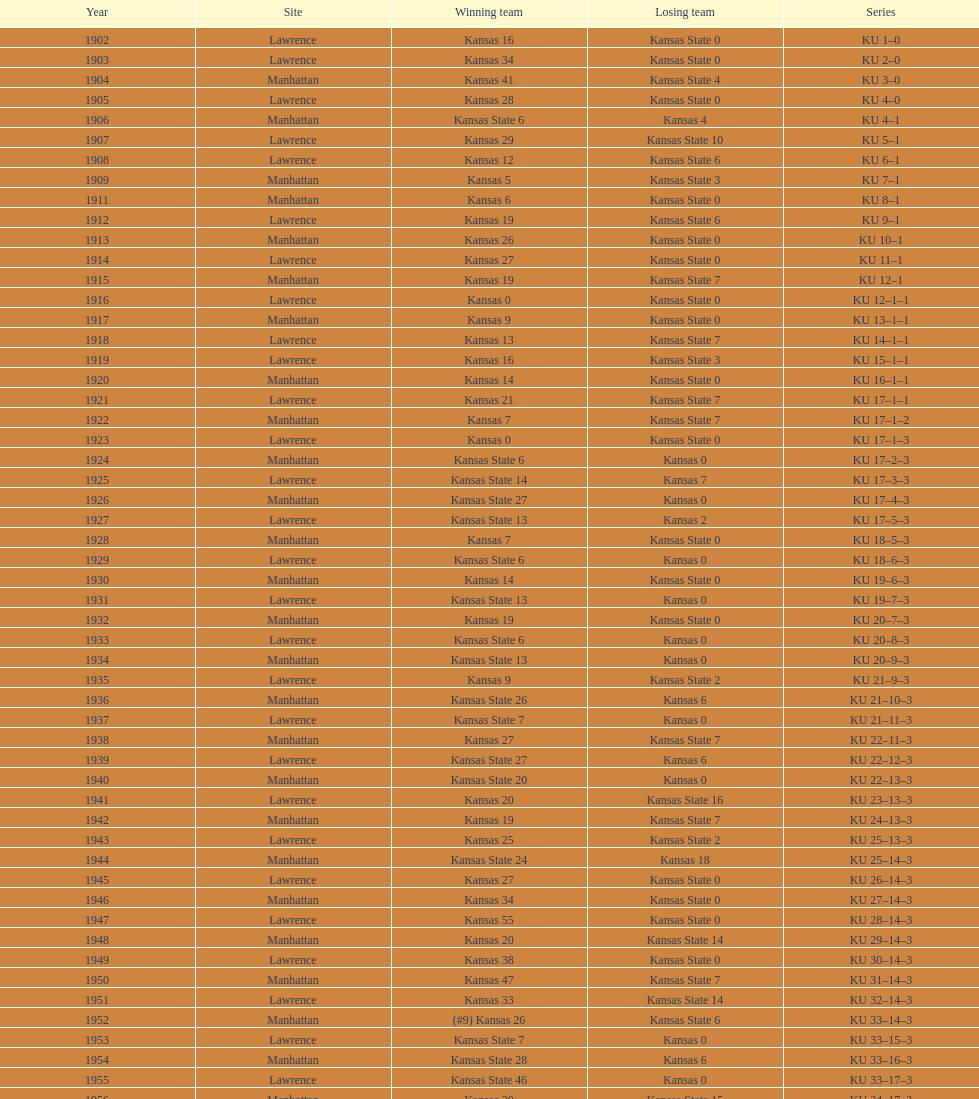When did kansas state secure their first win with a difference of ten or more points? 1926. 